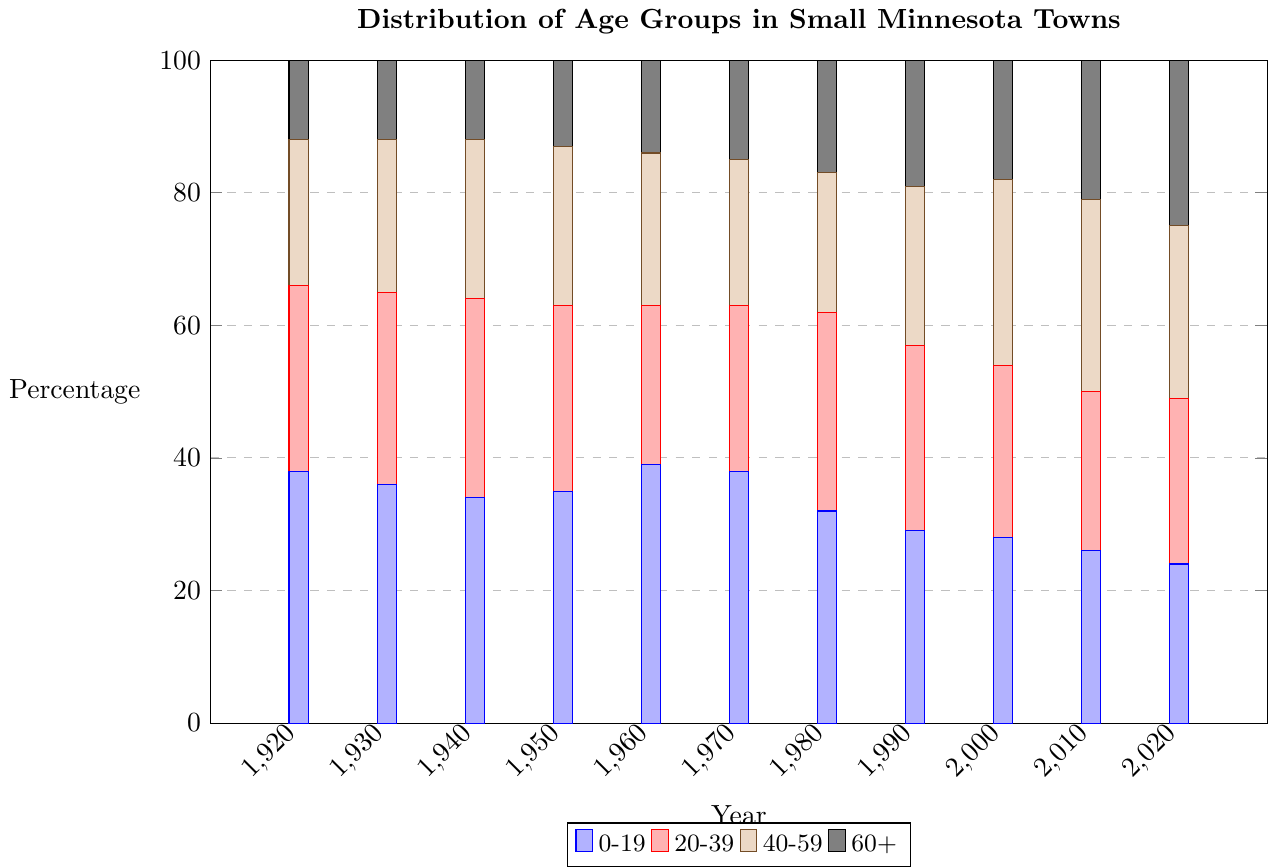Which age group had the highest percentage in 1920? Look at the bar chart's x-axis for 1920 and compare the heights of the bars representing different age groups. The tallest bar indicates the highest percentage.
Answer: 0-19 Which age group had the largest percentage increase from 1920 to 2020? Compare the heights of the bars for each age group between 1920 and 2020. Determine the difference in percentage for each age group and identify the largest increase. The 60+ age group increased from 12% in 1920 to 25% in 2020, a change of 13%.
Answer: 60+ In which year did the 20-39 age group reach its peak percentage? Inspect the heights of the bars for the 20-39 age group across all years on the x-axis. The year with the tallest 20-39 bar represents the peak percentage.
Answer: 1980 When did the percentage of the 0-19 age group first drop below 30%? Observe the heights of the 0-19 bars across the years and identify the first year when the bar height is below the 30% mark.
Answer: 1990 What was the combined percentage of the 40-59 and 60+ age groups in 2010? Add the heights of the bars for the 40-59 and 60+ age groups in 2010. The bars represent 29% and 21%, respectively. Thus, the sum is 29% + 21%.
Answer: 50% How many years show an increasing trend in the percentage of the 60+ age group? Evaluate the heights of the 60+ bars from year to year and count how many times there is an upward movement from one bar to the next. The heights of the 60+ bars increase in 1950, 1960, 1970, 1980, 1990, 2010, and 2020.
Answer: 7 years Compare the percentages of the 0-19 and 40-59 age groups in 2000. Which one is higher and by how much? Look at the respective bars for 2000 and subtract the height of the 40-59 bar from the height of the 0-19 bar. 28% (0-19) - 28% (40-59) gives a difference of 0%.
Answer: Equal (0%) Between which two consecutive decades did the 20-39 age group see the largest decline in percentage? Inspect the percentage drop in the 20-39 bars between each pair of consecutive decades. Calculate the differences and compare them to find the largest drop. The largest drop is between 1940 (30%) and 1960 (24%) with a decline of 6%.
Answer: 1940 to 1960 What is the average percentage of the 60+ age group over the century? Summarize the heights of the 60+ bars across all years and then divide by the number of years. Total = 12+12+12+13+14+15+17+19+18+21+25 = 178. Average = 178/11
Answer: 16.18% In what year did the 40-59 age group percentage match the 0-19 age group? Look for the year where the heights of the 40-59 and 0-19 bars are equal. In 2000, both age groups have a percentage of 28%.
Answer: 2000 